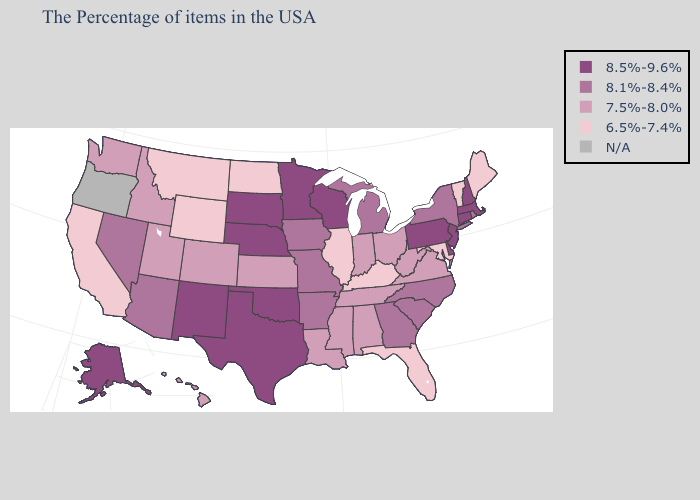Does Montana have the lowest value in the USA?
Give a very brief answer. Yes. Does the first symbol in the legend represent the smallest category?
Short answer required. No. Name the states that have a value in the range 8.1%-8.4%?
Short answer required. Rhode Island, New York, North Carolina, South Carolina, Georgia, Michigan, Missouri, Arkansas, Iowa, Arizona, Nevada. Does the first symbol in the legend represent the smallest category?
Answer briefly. No. Name the states that have a value in the range N/A?
Be succinct. Oregon. Which states have the lowest value in the South?
Give a very brief answer. Maryland, Florida, Kentucky. Is the legend a continuous bar?
Give a very brief answer. No. Does the first symbol in the legend represent the smallest category?
Concise answer only. No. Name the states that have a value in the range 8.1%-8.4%?
Write a very short answer. Rhode Island, New York, North Carolina, South Carolina, Georgia, Michigan, Missouri, Arkansas, Iowa, Arizona, Nevada. What is the value of Connecticut?
Short answer required. 8.5%-9.6%. Name the states that have a value in the range N/A?
Answer briefly. Oregon. What is the value of Florida?
Short answer required. 6.5%-7.4%. Does the first symbol in the legend represent the smallest category?
Quick response, please. No. Does Alaska have the highest value in the USA?
Concise answer only. Yes. 